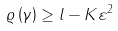<formula> <loc_0><loc_0><loc_500><loc_500>\varrho \left ( \gamma \right ) \geq l - K \varepsilon ^ { 2 }</formula> 